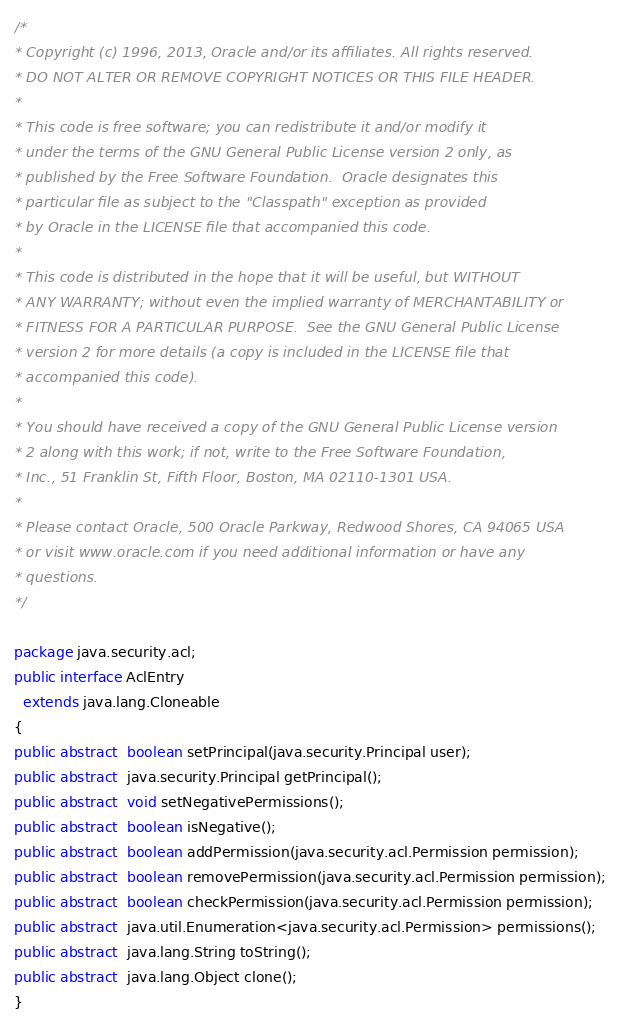Convert code to text. <code><loc_0><loc_0><loc_500><loc_500><_Java_>/*
* Copyright (c) 1996, 2013, Oracle and/or its affiliates. All rights reserved.
* DO NOT ALTER OR REMOVE COPYRIGHT NOTICES OR THIS FILE HEADER.
*
* This code is free software; you can redistribute it and/or modify it
* under the terms of the GNU General Public License version 2 only, as
* published by the Free Software Foundation.  Oracle designates this
* particular file as subject to the "Classpath" exception as provided
* by Oracle in the LICENSE file that accompanied this code.
*
* This code is distributed in the hope that it will be useful, but WITHOUT
* ANY WARRANTY; without even the implied warranty of MERCHANTABILITY or
* FITNESS FOR A PARTICULAR PURPOSE.  See the GNU General Public License
* version 2 for more details (a copy is included in the LICENSE file that
* accompanied this code).
*
* You should have received a copy of the GNU General Public License version
* 2 along with this work; if not, write to the Free Software Foundation,
* Inc., 51 Franklin St, Fifth Floor, Boston, MA 02110-1301 USA.
*
* Please contact Oracle, 500 Oracle Parkway, Redwood Shores, CA 94065 USA
* or visit www.oracle.com if you need additional information or have any
* questions.
*/

package java.security.acl;
public interface AclEntry
  extends java.lang.Cloneable
{
public abstract  boolean setPrincipal(java.security.Principal user);
public abstract  java.security.Principal getPrincipal();
public abstract  void setNegativePermissions();
public abstract  boolean isNegative();
public abstract  boolean addPermission(java.security.acl.Permission permission);
public abstract  boolean removePermission(java.security.acl.Permission permission);
public abstract  boolean checkPermission(java.security.acl.Permission permission);
public abstract  java.util.Enumeration<java.security.acl.Permission> permissions();
public abstract  java.lang.String toString();
public abstract  java.lang.Object clone();
}
</code> 